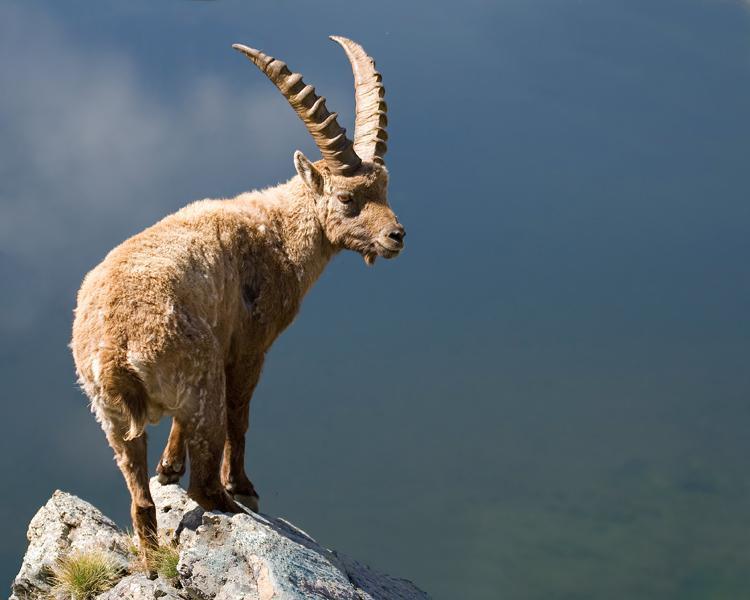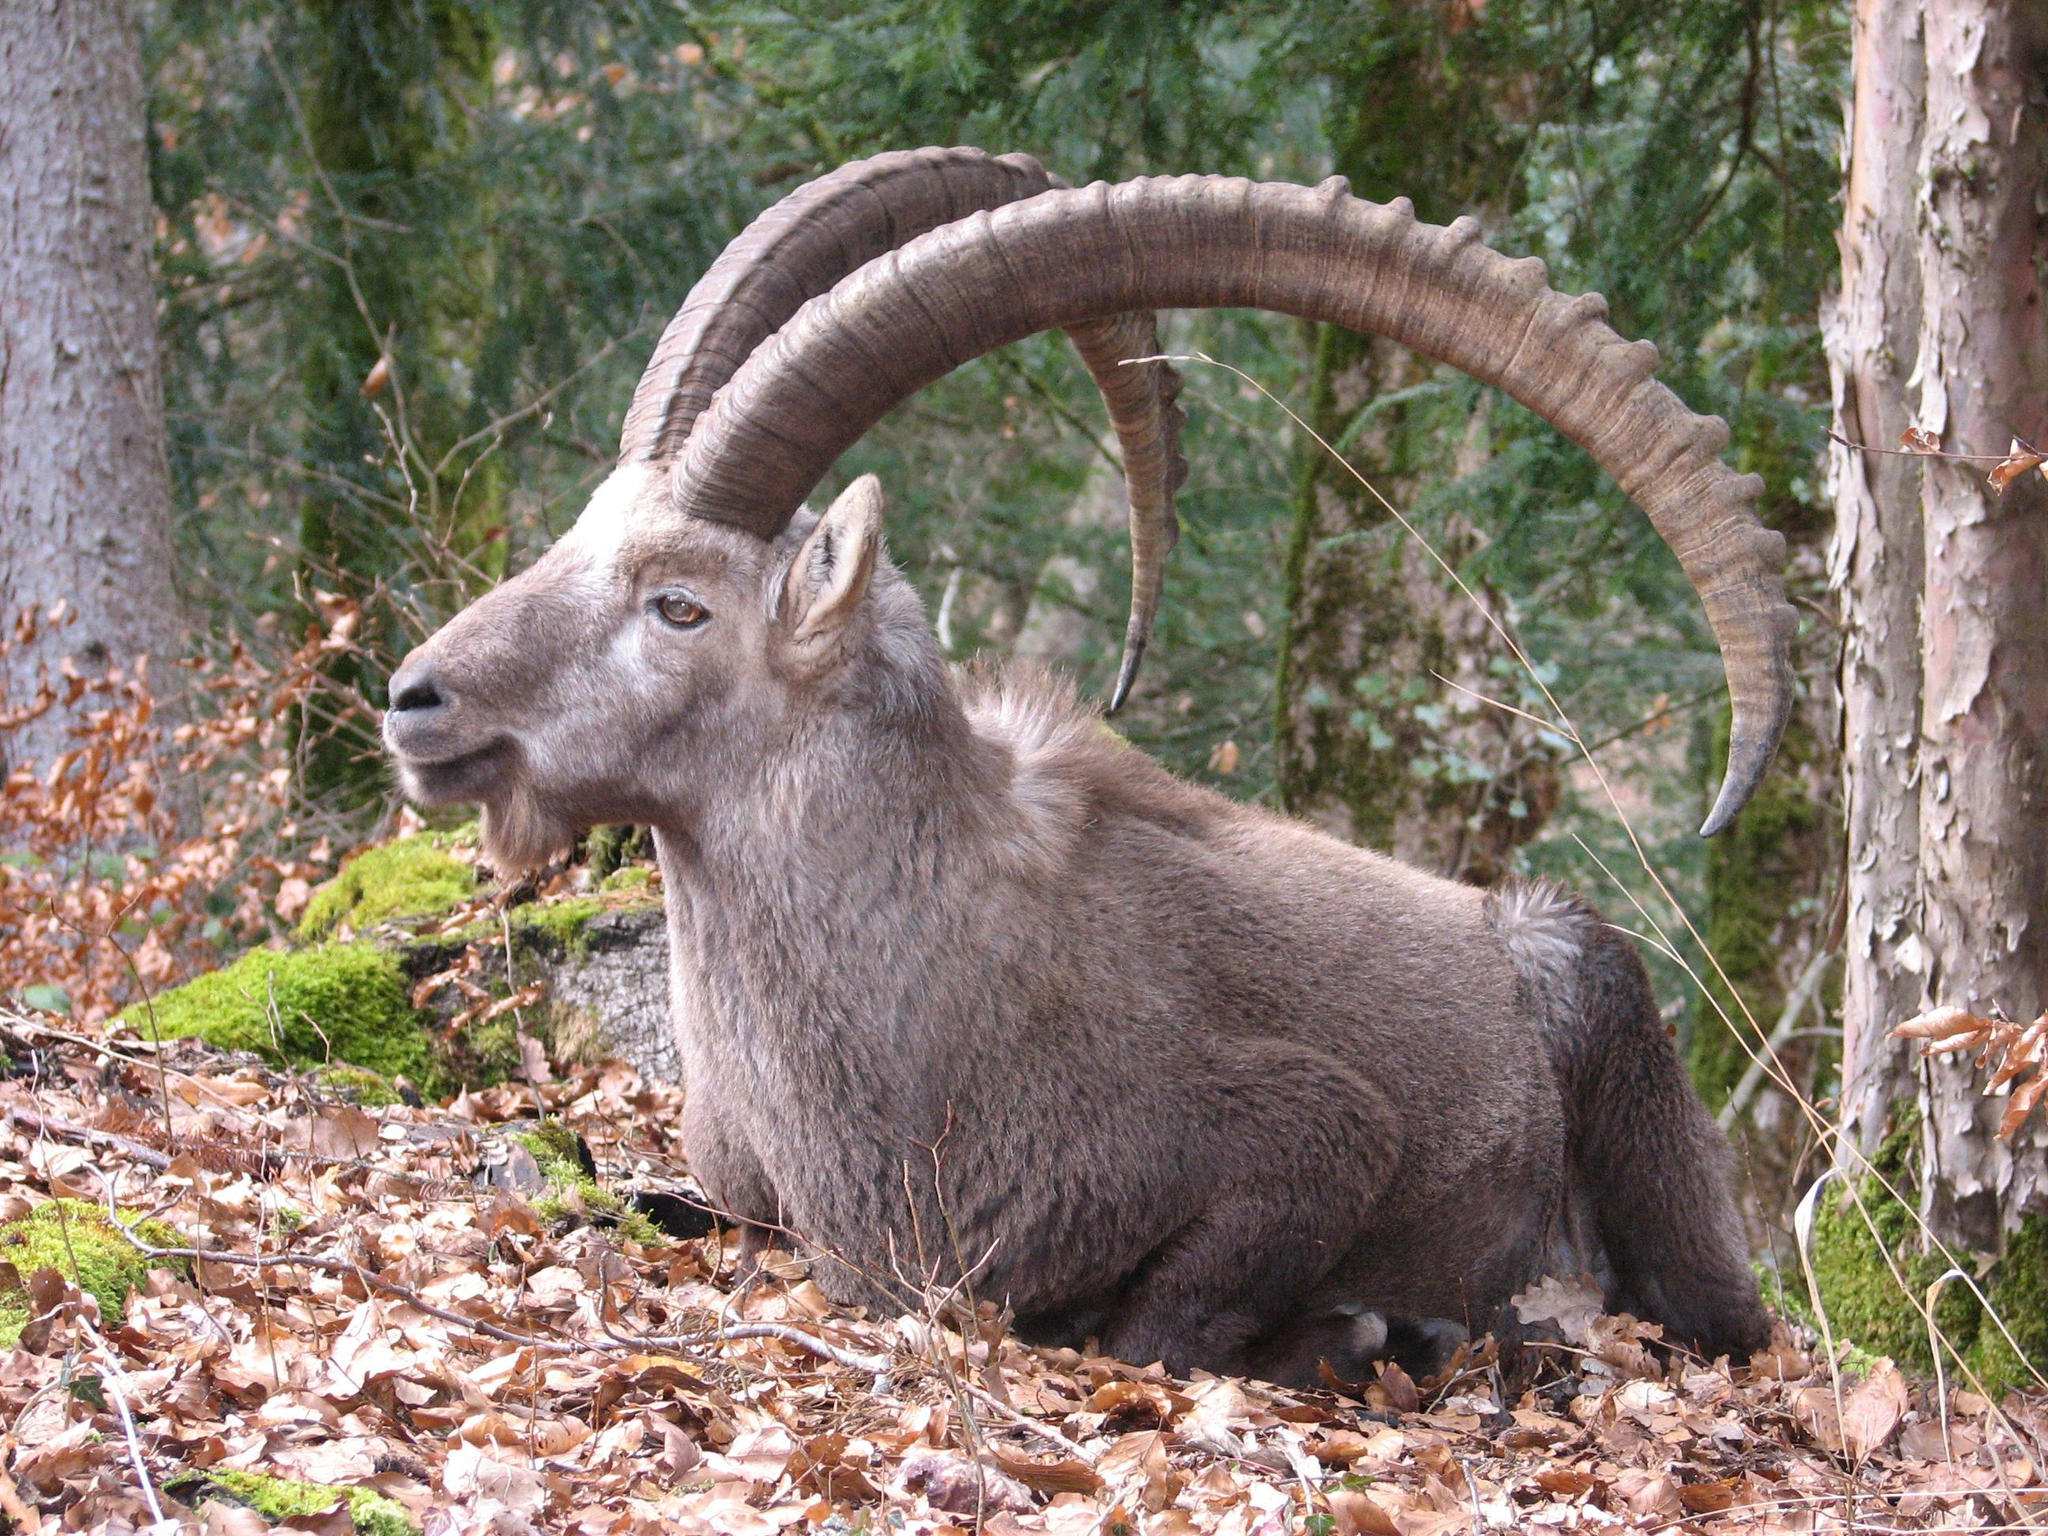The first image is the image on the left, the second image is the image on the right. Examine the images to the left and right. Is the description "One animal with curved horns is laying on the ground and one animal is standing at the peak of something." accurate? Answer yes or no. Yes. 